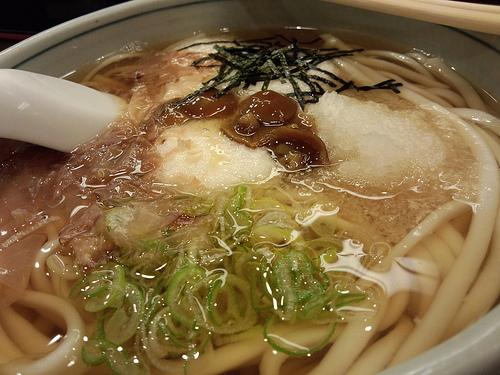How would you describe the appearance of the soup served in the bowl? The soup has a clear broth, green spices, white noodles, and assorted green vegetables, mushrooms, and onions. What are the main ingredients visible in this soup? Green onions, mushrooms, noodles, and clear broth with floating green spices. What type of food appears to be in string-like shape in the image? The food that looks like a black string might be noodles in the soup. Identify the main object in the scene and briefly mention its characteristics. The main object is a bowl of Asian style hot soup with green onions, mushrooms, and noodles, served in a white porcelain bowl with blue trim. What type of dish is portrayed in the image? A bowl of Asian style hot soup with various ingredients such as green onions, mushrooms, and noodles. Count the number of main food elements present in the soup. There are at least six main food elements in the soup including green onions, mushrooms, noodles, green spices, broth, and some pieces of unidentified brown food. Explain the interaction between the spoon and the bowl in the image. The handle of the spoon is submerged in the soup, with its tip resting on the edge of the bowl, and light reflecting off its surface. What colors can be seen in the image?  White, blue, green, and shades of brown can be seen in the image. What is the overall sentiment or feeling conveyed by the image? The image conveys a feeling of warmth, comfort, and satisfaction with the inviting bowl of hot soup, which is a symbol of nourishment and delicious flavors. Describe the utensil found in the image. The utensil is a spoon with a handle submerged in the soup and reflecting light off its surface. 